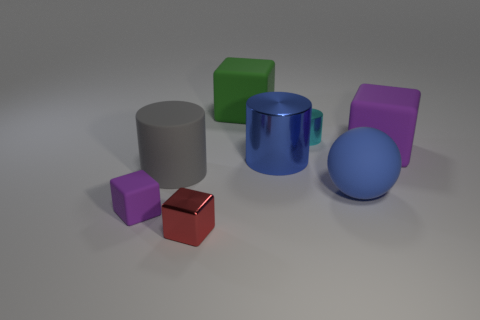Do the large shiny cylinder and the ball have the same color?
Offer a very short reply. Yes. What shape is the object that is the same color as the big matte sphere?
Keep it short and to the point. Cylinder. Does the green block have the same size as the purple thing to the right of the tiny cylinder?
Your answer should be compact. Yes. Are there any other things that are the same shape as the gray thing?
Offer a very short reply. Yes. The ball is what size?
Your response must be concise. Large. Is the number of large blue cylinders left of the tiny metallic cube less than the number of cyan cylinders?
Keep it short and to the point. Yes. Does the cyan metal object have the same size as the gray cylinder?
Make the answer very short. No. Is there any other thing that is the same size as the green cube?
Your answer should be very brief. Yes. What is the color of the large cylinder that is made of the same material as the tiny cylinder?
Give a very brief answer. Blue. Is the number of big cylinders behind the large purple cube less than the number of large blue cylinders on the left side of the tiny purple rubber cube?
Give a very brief answer. No. 